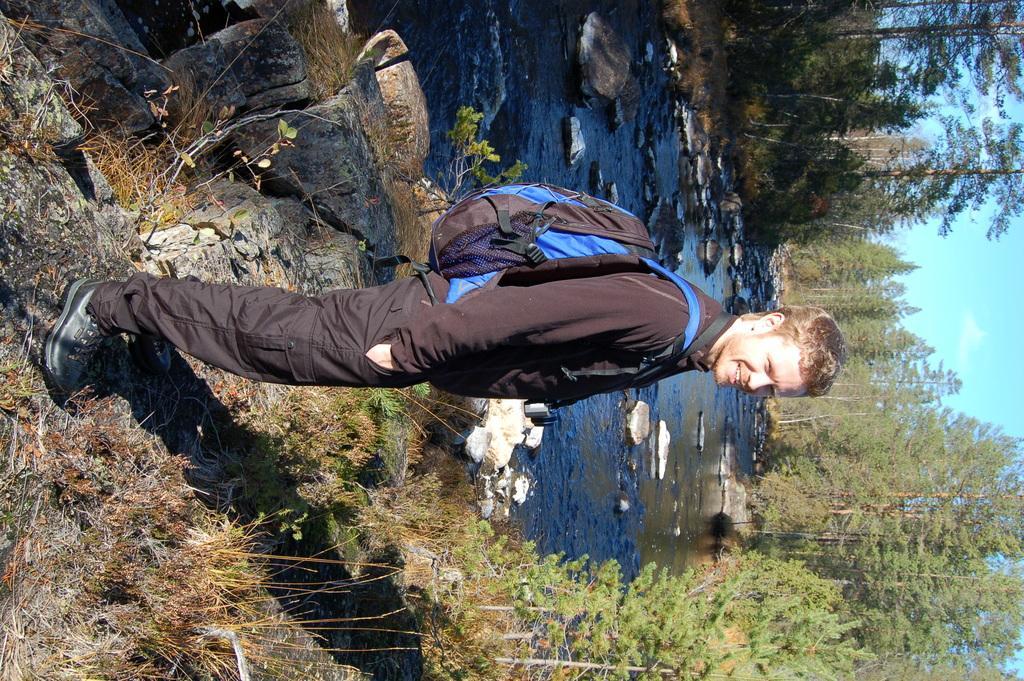How would you summarize this image in a sentence or two? In the image we can see there is a man standing and he is carrying bag. There is grass on the ground and behind there is water. There are lot of trees at the back and there is a clear sky. 